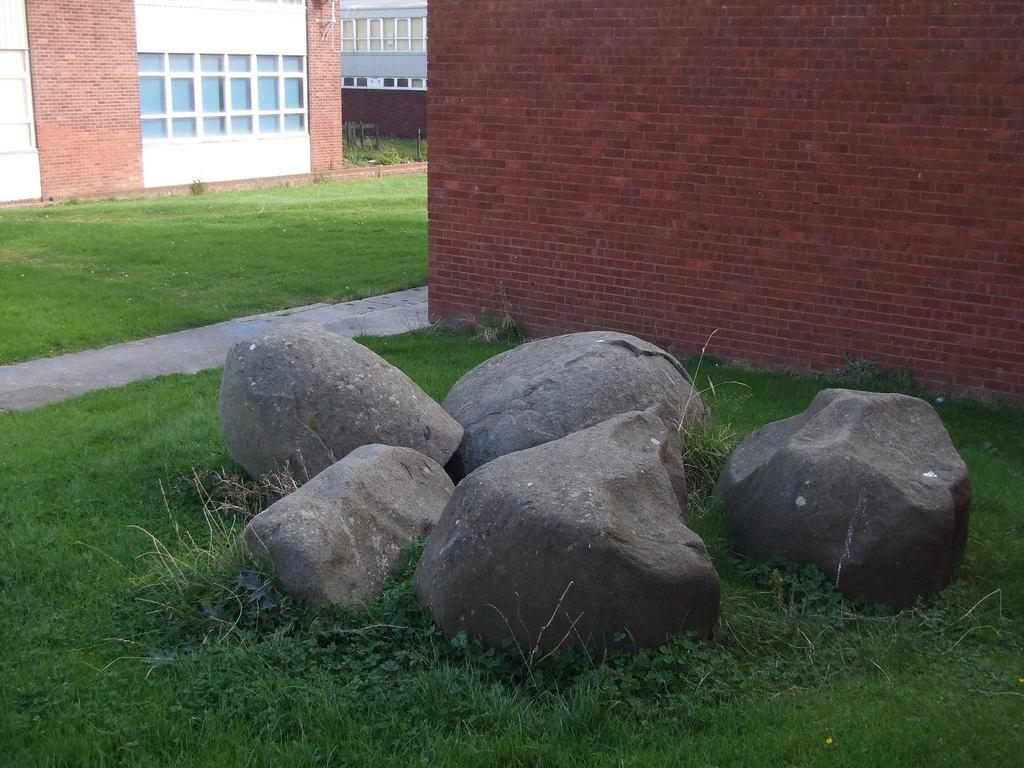What type of surface is visible on the ground in the image? There is grass and stones on the ground in the image. What can be seen on the right side of the image? There is a brick wall on the right side of the image. What type of structures are visible on the left side of the image? There are buildings with windows on the left side of the image. What type of sail can be seen on the grass in the image? There is no sail present in the image; it features grass, stones, a brick wall, and buildings with windows. How many whips are visible in the image? There are no whips present in the image. 